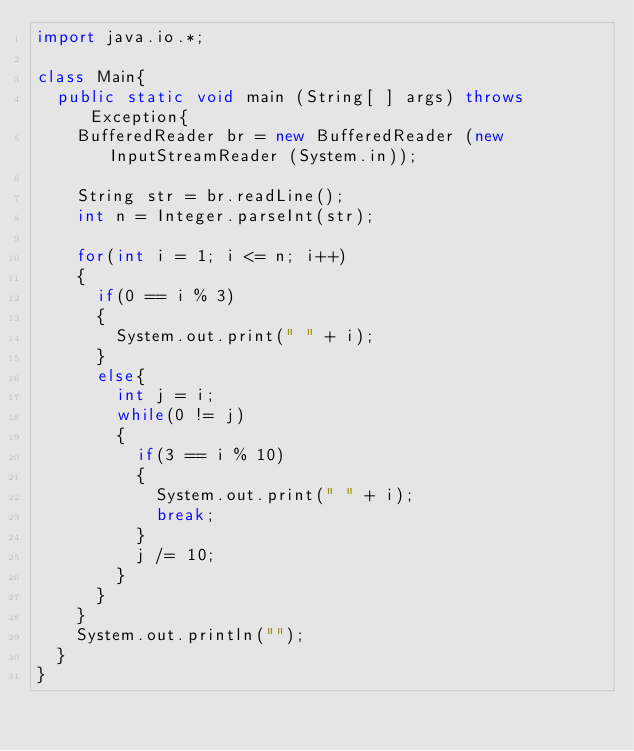Convert code to text. <code><loc_0><loc_0><loc_500><loc_500><_Java_>import java.io.*;

class Main{
	public static void main (String[ ] args) throws Exception{
		BufferedReader br = new BufferedReader (new InputStreamReader (System.in));

		String str = br.readLine();
		int n = Integer.parseInt(str);

		for(int i = 1; i <= n; i++)
		{
			if(0 == i % 3)
			{
				System.out.print(" " + i);
			}
			else{
				int j = i;
				while(0 != j)
				{
					if(3 == i % 10)
					{
						System.out.print(" " + i);
						break;
					}
					j /= 10;
				}
			}
		}
		System.out.println("");
	}
}</code> 